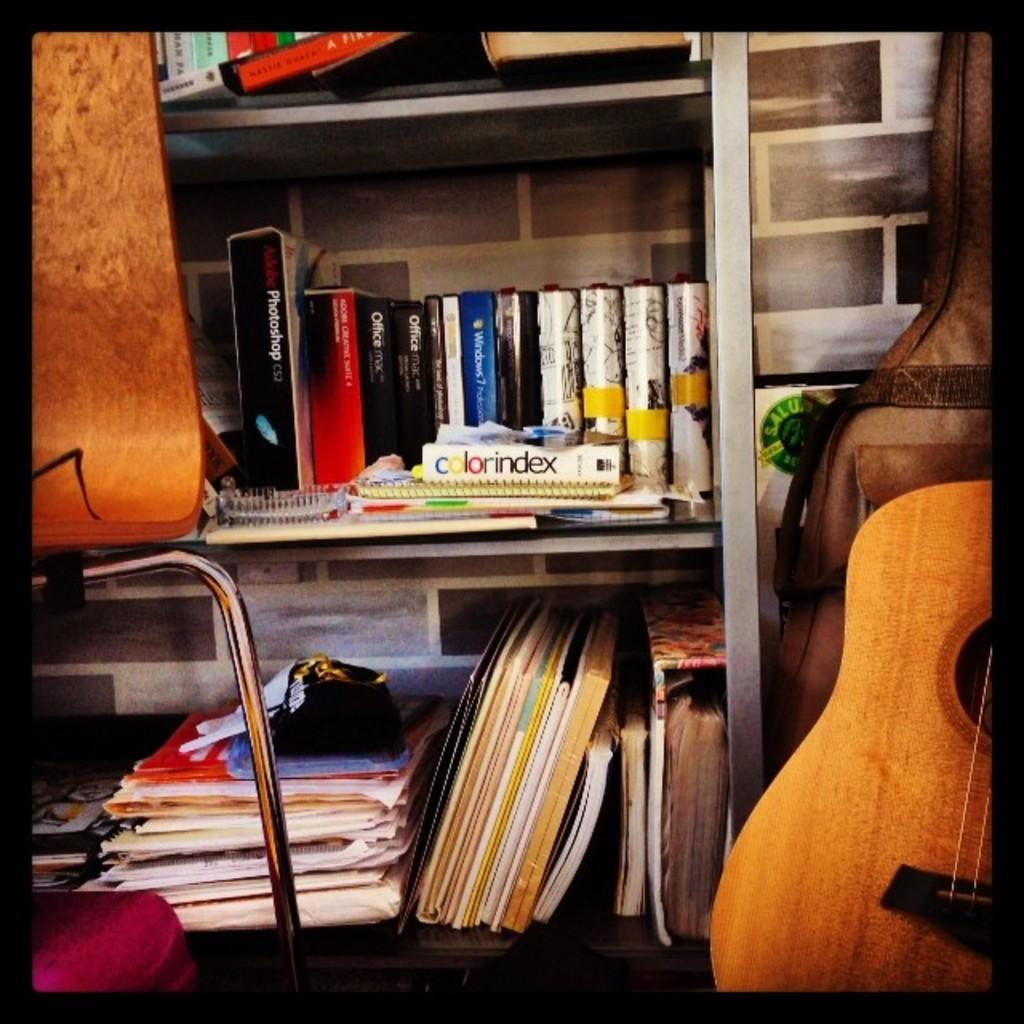<image>
Write a terse but informative summary of the picture. Messy stand showing a white box in the middle titled Color index. 